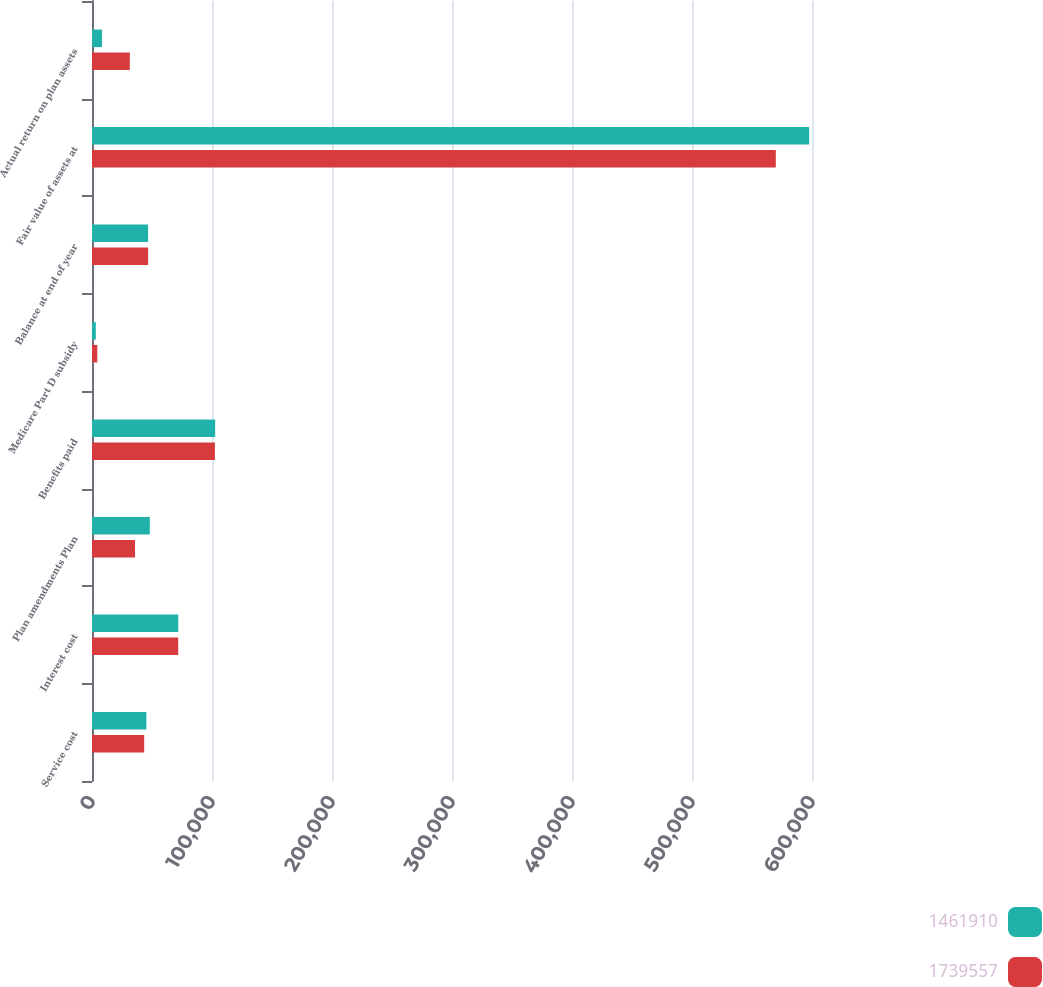Convert chart to OTSL. <chart><loc_0><loc_0><loc_500><loc_500><stacked_bar_chart><ecel><fcel>Service cost<fcel>Interest cost<fcel>Plan amendments Plan<fcel>Benefits paid<fcel>Medicare Part D subsidy<fcel>Balance at end of year<fcel>Fair value of assets at<fcel>Actual return on plan assets<nl><fcel>1.46191e+06<fcel>45305<fcel>71934<fcel>48192<fcel>102618<fcel>3175<fcel>46748.5<fcel>597627<fcel>8303<nl><fcel>1.73956e+06<fcel>43493<fcel>71841<fcel>35864<fcel>102439<fcel>4395<fcel>46748.5<fcel>569850<fcel>31535<nl></chart> 